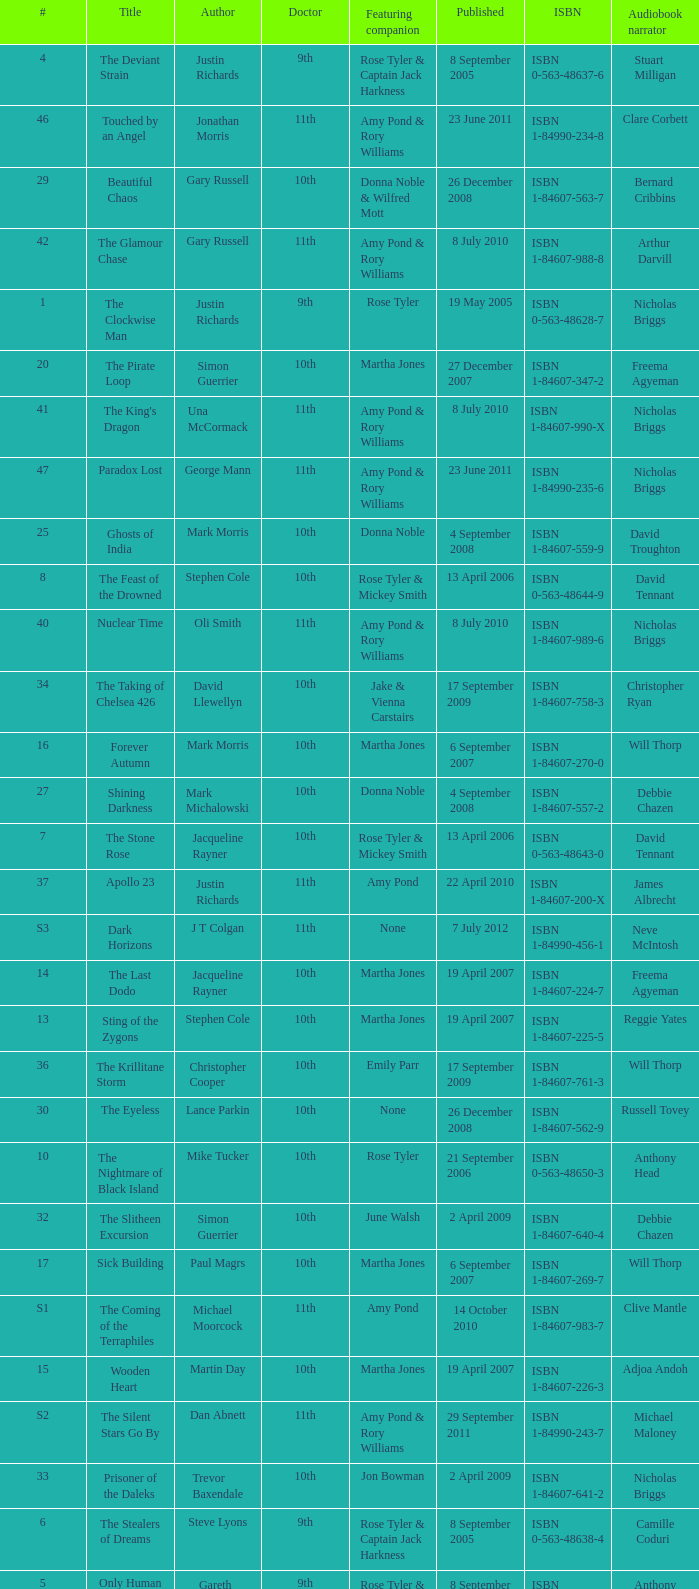What is the title of book number 7? The Stone Rose. Could you parse the entire table as a dict? {'header': ['#', 'Title', 'Author', 'Doctor', 'Featuring companion', 'Published', 'ISBN', 'Audiobook narrator'], 'rows': [['4', 'The Deviant Strain', 'Justin Richards', '9th', 'Rose Tyler & Captain Jack Harkness', '8 September 2005', 'ISBN 0-563-48637-6', 'Stuart Milligan'], ['46', 'Touched by an Angel', 'Jonathan Morris', '11th', 'Amy Pond & Rory Williams', '23 June 2011', 'ISBN 1-84990-234-8', 'Clare Corbett'], ['29', 'Beautiful Chaos', 'Gary Russell', '10th', 'Donna Noble & Wilfred Mott', '26 December 2008', 'ISBN 1-84607-563-7', 'Bernard Cribbins'], ['42', 'The Glamour Chase', 'Gary Russell', '11th', 'Amy Pond & Rory Williams', '8 July 2010', 'ISBN 1-84607-988-8', 'Arthur Darvill'], ['1', 'The Clockwise Man', 'Justin Richards', '9th', 'Rose Tyler', '19 May 2005', 'ISBN 0-563-48628-7', 'Nicholas Briggs'], ['20', 'The Pirate Loop', 'Simon Guerrier', '10th', 'Martha Jones', '27 December 2007', 'ISBN 1-84607-347-2', 'Freema Agyeman'], ['41', "The King's Dragon", 'Una McCormack', '11th', 'Amy Pond & Rory Williams', '8 July 2010', 'ISBN 1-84607-990-X', 'Nicholas Briggs'], ['47', 'Paradox Lost', 'George Mann', '11th', 'Amy Pond & Rory Williams', '23 June 2011', 'ISBN 1-84990-235-6', 'Nicholas Briggs'], ['25', 'Ghosts of India', 'Mark Morris', '10th', 'Donna Noble', '4 September 2008', 'ISBN 1-84607-559-9', 'David Troughton'], ['8', 'The Feast of the Drowned', 'Stephen Cole', '10th', 'Rose Tyler & Mickey Smith', '13 April 2006', 'ISBN 0-563-48644-9', 'David Tennant'], ['40', 'Nuclear Time', 'Oli Smith', '11th', 'Amy Pond & Rory Williams', '8 July 2010', 'ISBN 1-84607-989-6', 'Nicholas Briggs'], ['34', 'The Taking of Chelsea 426', 'David Llewellyn', '10th', 'Jake & Vienna Carstairs', '17 September 2009', 'ISBN 1-84607-758-3', 'Christopher Ryan'], ['16', 'Forever Autumn', 'Mark Morris', '10th', 'Martha Jones', '6 September 2007', 'ISBN 1-84607-270-0', 'Will Thorp'], ['27', 'Shining Darkness', 'Mark Michalowski', '10th', 'Donna Noble', '4 September 2008', 'ISBN 1-84607-557-2', 'Debbie Chazen'], ['7', 'The Stone Rose', 'Jacqueline Rayner', '10th', 'Rose Tyler & Mickey Smith', '13 April 2006', 'ISBN 0-563-48643-0', 'David Tennant'], ['37', 'Apollo 23', 'Justin Richards', '11th', 'Amy Pond', '22 April 2010', 'ISBN 1-84607-200-X', 'James Albrecht'], ['S3', 'Dark Horizons', 'J T Colgan', '11th', 'None', '7 July 2012', 'ISBN 1-84990-456-1', 'Neve McIntosh'], ['14', 'The Last Dodo', 'Jacqueline Rayner', '10th', 'Martha Jones', '19 April 2007', 'ISBN 1-84607-224-7', 'Freema Agyeman'], ['13', 'Sting of the Zygons', 'Stephen Cole', '10th', 'Martha Jones', '19 April 2007', 'ISBN 1-84607-225-5', 'Reggie Yates'], ['36', 'The Krillitane Storm', 'Christopher Cooper', '10th', 'Emily Parr', '17 September 2009', 'ISBN 1-84607-761-3', 'Will Thorp'], ['30', 'The Eyeless', 'Lance Parkin', '10th', 'None', '26 December 2008', 'ISBN 1-84607-562-9', 'Russell Tovey'], ['10', 'The Nightmare of Black Island', 'Mike Tucker', '10th', 'Rose Tyler', '21 September 2006', 'ISBN 0-563-48650-3', 'Anthony Head'], ['32', 'The Slitheen Excursion', 'Simon Guerrier', '10th', 'June Walsh', '2 April 2009', 'ISBN 1-84607-640-4', 'Debbie Chazen'], ['17', 'Sick Building', 'Paul Magrs', '10th', 'Martha Jones', '6 September 2007', 'ISBN 1-84607-269-7', 'Will Thorp'], ['S1', 'The Coming of the Terraphiles', 'Michael Moorcock', '11th', 'Amy Pond', '14 October 2010', 'ISBN 1-84607-983-7', 'Clive Mantle'], ['15', 'Wooden Heart', 'Martin Day', '10th', 'Martha Jones', '19 April 2007', 'ISBN 1-84607-226-3', 'Adjoa Andoh'], ['S2', 'The Silent Stars Go By', 'Dan Abnett', '11th', 'Amy Pond & Rory Williams', '29 September 2011', 'ISBN 1-84990-243-7', 'Michael Maloney'], ['33', 'Prisoner of the Daleks', 'Trevor Baxendale', '10th', 'Jon Bowman', '2 April 2009', 'ISBN 1-84607-641-2', 'Nicholas Briggs'], ['6', 'The Stealers of Dreams', 'Steve Lyons', '9th', 'Rose Tyler & Captain Jack Harkness', '8 September 2005', 'ISBN 0-563-48638-4', 'Camille Coduri'], ['5', 'Only Human', 'Gareth Roberts', '9th', 'Rose Tyler & Captain Jack Harkness', '8 September 2005', 'ISBN 0-563-48639-2', 'Anthony Head'], ['23', 'Snowglobe 7', 'Mike Tucker', '10th', 'Martha Jones', '1 May 2008', 'ISBN 1-84607-421-5', 'Georgia Moffett'], ['24', 'The Many Hands', 'Dale Smith', '10th', 'Martha Jones', '1 May 2008', 'ISBN 1-84607-422-3', 'David Troughton'], ['39', 'The Forgotten Army', 'Brian Minchin', '11th', 'Amy Pond', '22 April 2010', 'ISBN 1-84607-987-X', 'Olivia Colman'], ['31', 'Judgement of the Judoon', 'Colin Brake', '10th', 'Nikki Jupiter', '2 April 2009', 'ISBN 1-84607-639-0', 'Nicholas Briggs'], ['43', 'Dead of Winter', 'James Goss', '11th', 'Amy Pond & Rory Williams', '28 April 2011', 'ISBN 1-84990-238-0', 'Clare Corbett'], ['44', 'The Way Through the Woods', 'Una McCormack', '11th', 'Amy Pond & Rory Williams', '28 April 2011', 'ISBN 1-84990-237-2', 'Clare Corbett'], ['35', 'Autonomy', 'Daniel Blythe', '10th', 'Kate Maguire', '17 September 2009', 'ISBN 1-84607-759-1', 'Georgia Moffett'], ['26', 'The Doctor Trap', 'Simon Messingham', '10th', 'Donna Noble', '4 September 2008', 'ISBN 1-84607-558-0', 'Russell Tovey'], ['38', 'Night of the Humans', 'David Llewellyn', '11th', 'Amy Pond', '22 April 2010', 'ISBN 1-84607-969-1', 'Arthur Darvill'], ['21', 'Peacemaker', 'James Swallow', '10th', 'Martha Jones', '27 December 2007', 'ISBN 1-84607-349-9', 'Will Thorp'], ['22', 'Martha in the Mirror', 'Justin Richards', '10th', 'Martha Jones', '1 May 2008', 'ISBN 1-84607-420-7', 'Freema Agyeman'], ['2', 'The Monsters Inside', 'Stephen Cole', '9th', 'Rose Tyler', '19 May 2005', 'ISBN 0-563-48629-5', 'Camille Coduri'], ['9', 'The Resurrection Casket', 'Justin Richards', '10th', 'Rose Tyler', '13 April 2006', 'ISBN 0-563-48642-2', 'David Tennant'], ['19', 'Wishing Well', 'Trevor Baxendale', '10th', 'Martha Jones', '27 December 2007', 'ISBN 1-84607-348-0', 'Debbie Chazen'], ['48', 'Borrowed Time', 'Naomi Alderman', '11th', 'Amy Pond & Rory Williams', '23 June 2011', 'ISBN 1-84990-233-X', 'Meera Syal'], ['3', 'Winner Takes All', 'Jacqueline Rayner', '9th', 'Rose Tyler & Mickey Smith', '19 May 2005', 'ISBN 0-563-48627-9', 'Camille Coduri'], ['11', 'The Art of Destruction', 'Stephen Cole', '10th', 'Rose Tyler', '21 September 2006', 'ISBN 0-563-48651-1', 'Don Warrington'], ['45', "Hunter's Moon", 'Paul Finch', '11th', 'Amy Pond & Rory Williams', '28 April 2011', 'ISBN 1-84990-236-4', 'Arthur Darvill'], ['18', 'Wetworld', 'Mark Michalowski', '10th', 'Martha Jones', '6 September 2007', 'ISBN 1-84607-271-9', 'Freema Agyeman'], ['28', 'The Story of Martha', 'Dan Abnett', '10th', 'Martha Jones', '26 December 2008', 'ISBN 1-84607-561-0', 'Freema Agyeman'], ['12', 'The Price of Paradise', 'Colin Brake', '10th', 'Rose Tyler', '21 September 2006', 'ISBN 0-563-48652-X', 'Shaun Dingwall']]} 